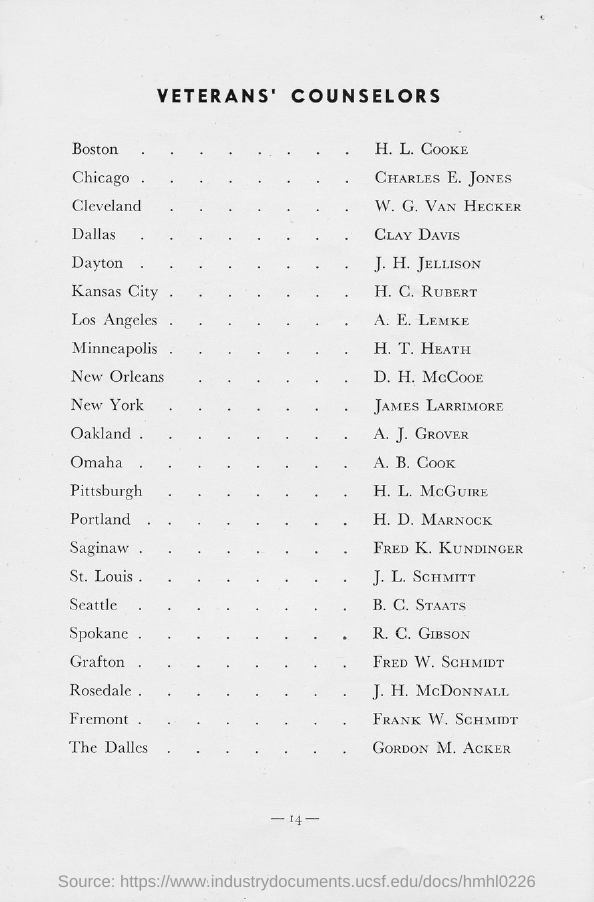What is the title of the document?
Give a very brief answer. Veteran's Counselors. 